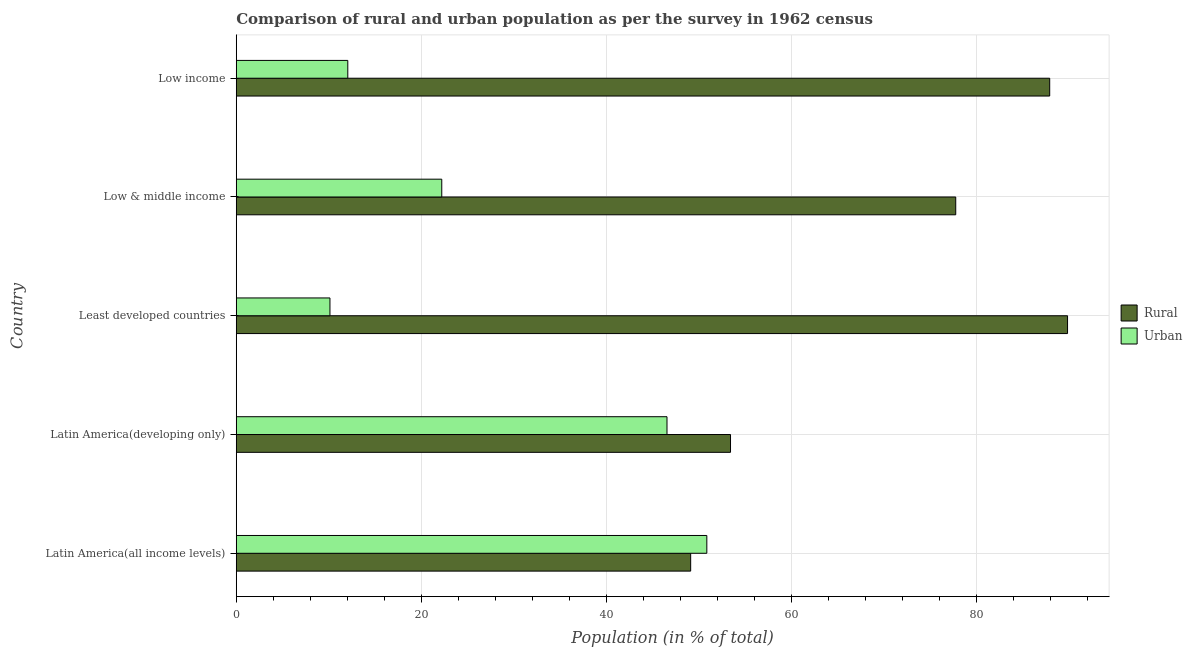How many groups of bars are there?
Provide a succinct answer. 5. Are the number of bars per tick equal to the number of legend labels?
Give a very brief answer. Yes. How many bars are there on the 4th tick from the top?
Your response must be concise. 2. How many bars are there on the 3rd tick from the bottom?
Your response must be concise. 2. What is the label of the 3rd group of bars from the top?
Keep it short and to the point. Least developed countries. What is the rural population in Latin America(developing only)?
Offer a terse response. 53.43. Across all countries, what is the maximum rural population?
Provide a short and direct response. 89.87. Across all countries, what is the minimum urban population?
Give a very brief answer. 10.13. In which country was the urban population maximum?
Give a very brief answer. Latin America(all income levels). In which country was the urban population minimum?
Your answer should be compact. Least developed countries. What is the total urban population in the graph?
Your response must be concise. 141.85. What is the difference between the rural population in Latin America(all income levels) and that in Latin America(developing only)?
Provide a succinct answer. -4.31. What is the difference between the rural population in Least developed countries and the urban population in Latin America(developing only)?
Give a very brief answer. 43.3. What is the average urban population per country?
Make the answer very short. 28.37. What is the difference between the urban population and rural population in Low & middle income?
Your answer should be very brief. -55.56. In how many countries, is the rural population greater than 16 %?
Give a very brief answer. 5. What is the ratio of the rural population in Least developed countries to that in Low & middle income?
Your answer should be very brief. 1.16. Is the urban population in Latin America(all income levels) less than that in Least developed countries?
Give a very brief answer. No. What is the difference between the highest and the second highest urban population?
Provide a succinct answer. 4.31. What is the difference between the highest and the lowest urban population?
Your answer should be very brief. 40.74. In how many countries, is the urban population greater than the average urban population taken over all countries?
Your response must be concise. 2. Is the sum of the rural population in Latin America(all income levels) and Low income greater than the maximum urban population across all countries?
Your answer should be very brief. Yes. What does the 1st bar from the top in Low & middle income represents?
Offer a very short reply. Urban. What does the 2nd bar from the bottom in Latin America(all income levels) represents?
Give a very brief answer. Urban. Are all the bars in the graph horizontal?
Keep it short and to the point. Yes. Does the graph contain any zero values?
Your answer should be compact. No. Does the graph contain grids?
Offer a very short reply. Yes. How many legend labels are there?
Keep it short and to the point. 2. How are the legend labels stacked?
Your answer should be compact. Vertical. What is the title of the graph?
Your answer should be compact. Comparison of rural and urban population as per the survey in 1962 census. Does "State government" appear as one of the legend labels in the graph?
Make the answer very short. No. What is the label or title of the X-axis?
Make the answer very short. Population (in % of total). What is the label or title of the Y-axis?
Provide a short and direct response. Country. What is the Population (in % of total) of Rural in Latin America(all income levels)?
Your answer should be compact. 49.13. What is the Population (in % of total) of Urban in Latin America(all income levels)?
Your answer should be very brief. 50.87. What is the Population (in % of total) of Rural in Latin America(developing only)?
Make the answer very short. 53.43. What is the Population (in % of total) in Urban in Latin America(developing only)?
Your answer should be compact. 46.57. What is the Population (in % of total) in Rural in Least developed countries?
Your response must be concise. 89.87. What is the Population (in % of total) in Urban in Least developed countries?
Your response must be concise. 10.13. What is the Population (in % of total) of Rural in Low & middle income?
Your answer should be very brief. 77.78. What is the Population (in % of total) of Urban in Low & middle income?
Make the answer very short. 22.22. What is the Population (in % of total) of Rural in Low income?
Provide a succinct answer. 87.94. What is the Population (in % of total) of Urban in Low income?
Offer a terse response. 12.06. Across all countries, what is the maximum Population (in % of total) of Rural?
Offer a terse response. 89.87. Across all countries, what is the maximum Population (in % of total) of Urban?
Offer a terse response. 50.87. Across all countries, what is the minimum Population (in % of total) in Rural?
Provide a short and direct response. 49.13. Across all countries, what is the minimum Population (in % of total) in Urban?
Make the answer very short. 10.13. What is the total Population (in % of total) in Rural in the graph?
Make the answer very short. 358.15. What is the total Population (in % of total) in Urban in the graph?
Make the answer very short. 141.85. What is the difference between the Population (in % of total) in Rural in Latin America(all income levels) and that in Latin America(developing only)?
Offer a terse response. -4.31. What is the difference between the Population (in % of total) in Urban in Latin America(all income levels) and that in Latin America(developing only)?
Ensure brevity in your answer.  4.31. What is the difference between the Population (in % of total) of Rural in Latin America(all income levels) and that in Least developed countries?
Your answer should be compact. -40.74. What is the difference between the Population (in % of total) in Urban in Latin America(all income levels) and that in Least developed countries?
Provide a short and direct response. 40.74. What is the difference between the Population (in % of total) in Rural in Latin America(all income levels) and that in Low & middle income?
Offer a terse response. -28.65. What is the difference between the Population (in % of total) in Urban in Latin America(all income levels) and that in Low & middle income?
Your response must be concise. 28.65. What is the difference between the Population (in % of total) of Rural in Latin America(all income levels) and that in Low income?
Offer a terse response. -38.81. What is the difference between the Population (in % of total) in Urban in Latin America(all income levels) and that in Low income?
Provide a succinct answer. 38.81. What is the difference between the Population (in % of total) of Rural in Latin America(developing only) and that in Least developed countries?
Keep it short and to the point. -36.44. What is the difference between the Population (in % of total) in Urban in Latin America(developing only) and that in Least developed countries?
Offer a terse response. 36.44. What is the difference between the Population (in % of total) in Rural in Latin America(developing only) and that in Low & middle income?
Make the answer very short. -24.35. What is the difference between the Population (in % of total) of Urban in Latin America(developing only) and that in Low & middle income?
Your response must be concise. 24.35. What is the difference between the Population (in % of total) of Rural in Latin America(developing only) and that in Low income?
Ensure brevity in your answer.  -34.51. What is the difference between the Population (in % of total) in Urban in Latin America(developing only) and that in Low income?
Provide a succinct answer. 34.51. What is the difference between the Population (in % of total) of Rural in Least developed countries and that in Low & middle income?
Offer a very short reply. 12.09. What is the difference between the Population (in % of total) in Urban in Least developed countries and that in Low & middle income?
Your response must be concise. -12.09. What is the difference between the Population (in % of total) of Rural in Least developed countries and that in Low income?
Offer a very short reply. 1.93. What is the difference between the Population (in % of total) of Urban in Least developed countries and that in Low income?
Your answer should be compact. -1.93. What is the difference between the Population (in % of total) in Rural in Low & middle income and that in Low income?
Keep it short and to the point. -10.16. What is the difference between the Population (in % of total) in Urban in Low & middle income and that in Low income?
Provide a succinct answer. 10.16. What is the difference between the Population (in % of total) of Rural in Latin America(all income levels) and the Population (in % of total) of Urban in Latin America(developing only)?
Provide a succinct answer. 2.56. What is the difference between the Population (in % of total) in Rural in Latin America(all income levels) and the Population (in % of total) in Urban in Least developed countries?
Give a very brief answer. 39. What is the difference between the Population (in % of total) in Rural in Latin America(all income levels) and the Population (in % of total) in Urban in Low & middle income?
Offer a terse response. 26.91. What is the difference between the Population (in % of total) in Rural in Latin America(all income levels) and the Population (in % of total) in Urban in Low income?
Offer a terse response. 37.07. What is the difference between the Population (in % of total) in Rural in Latin America(developing only) and the Population (in % of total) in Urban in Least developed countries?
Provide a short and direct response. 43.3. What is the difference between the Population (in % of total) in Rural in Latin America(developing only) and the Population (in % of total) in Urban in Low & middle income?
Ensure brevity in your answer.  31.22. What is the difference between the Population (in % of total) in Rural in Latin America(developing only) and the Population (in % of total) in Urban in Low income?
Ensure brevity in your answer.  41.37. What is the difference between the Population (in % of total) in Rural in Least developed countries and the Population (in % of total) in Urban in Low & middle income?
Provide a succinct answer. 67.65. What is the difference between the Population (in % of total) in Rural in Least developed countries and the Population (in % of total) in Urban in Low income?
Keep it short and to the point. 77.81. What is the difference between the Population (in % of total) of Rural in Low & middle income and the Population (in % of total) of Urban in Low income?
Offer a very short reply. 65.72. What is the average Population (in % of total) of Rural per country?
Your answer should be compact. 71.63. What is the average Population (in % of total) in Urban per country?
Offer a very short reply. 28.37. What is the difference between the Population (in % of total) of Rural and Population (in % of total) of Urban in Latin America(all income levels)?
Provide a short and direct response. -1.75. What is the difference between the Population (in % of total) in Rural and Population (in % of total) in Urban in Latin America(developing only)?
Your response must be concise. 6.87. What is the difference between the Population (in % of total) in Rural and Population (in % of total) in Urban in Least developed countries?
Provide a succinct answer. 79.74. What is the difference between the Population (in % of total) in Rural and Population (in % of total) in Urban in Low & middle income?
Offer a very short reply. 55.56. What is the difference between the Population (in % of total) in Rural and Population (in % of total) in Urban in Low income?
Provide a short and direct response. 75.88. What is the ratio of the Population (in % of total) in Rural in Latin America(all income levels) to that in Latin America(developing only)?
Provide a short and direct response. 0.92. What is the ratio of the Population (in % of total) in Urban in Latin America(all income levels) to that in Latin America(developing only)?
Offer a very short reply. 1.09. What is the ratio of the Population (in % of total) of Rural in Latin America(all income levels) to that in Least developed countries?
Your answer should be very brief. 0.55. What is the ratio of the Population (in % of total) in Urban in Latin America(all income levels) to that in Least developed countries?
Your answer should be very brief. 5.02. What is the ratio of the Population (in % of total) of Rural in Latin America(all income levels) to that in Low & middle income?
Your response must be concise. 0.63. What is the ratio of the Population (in % of total) of Urban in Latin America(all income levels) to that in Low & middle income?
Your response must be concise. 2.29. What is the ratio of the Population (in % of total) in Rural in Latin America(all income levels) to that in Low income?
Your answer should be very brief. 0.56. What is the ratio of the Population (in % of total) in Urban in Latin America(all income levels) to that in Low income?
Offer a very short reply. 4.22. What is the ratio of the Population (in % of total) of Rural in Latin America(developing only) to that in Least developed countries?
Your answer should be very brief. 0.59. What is the ratio of the Population (in % of total) in Urban in Latin America(developing only) to that in Least developed countries?
Your answer should be very brief. 4.6. What is the ratio of the Population (in % of total) in Rural in Latin America(developing only) to that in Low & middle income?
Your answer should be very brief. 0.69. What is the ratio of the Population (in % of total) in Urban in Latin America(developing only) to that in Low & middle income?
Give a very brief answer. 2.1. What is the ratio of the Population (in % of total) of Rural in Latin America(developing only) to that in Low income?
Provide a succinct answer. 0.61. What is the ratio of the Population (in % of total) of Urban in Latin America(developing only) to that in Low income?
Your response must be concise. 3.86. What is the ratio of the Population (in % of total) of Rural in Least developed countries to that in Low & middle income?
Offer a terse response. 1.16. What is the ratio of the Population (in % of total) of Urban in Least developed countries to that in Low & middle income?
Offer a very short reply. 0.46. What is the ratio of the Population (in % of total) in Rural in Least developed countries to that in Low income?
Give a very brief answer. 1.02. What is the ratio of the Population (in % of total) in Urban in Least developed countries to that in Low income?
Your answer should be very brief. 0.84. What is the ratio of the Population (in % of total) in Rural in Low & middle income to that in Low income?
Offer a very short reply. 0.88. What is the ratio of the Population (in % of total) of Urban in Low & middle income to that in Low income?
Keep it short and to the point. 1.84. What is the difference between the highest and the second highest Population (in % of total) in Rural?
Offer a very short reply. 1.93. What is the difference between the highest and the second highest Population (in % of total) of Urban?
Keep it short and to the point. 4.31. What is the difference between the highest and the lowest Population (in % of total) of Rural?
Keep it short and to the point. 40.74. What is the difference between the highest and the lowest Population (in % of total) in Urban?
Your answer should be compact. 40.74. 